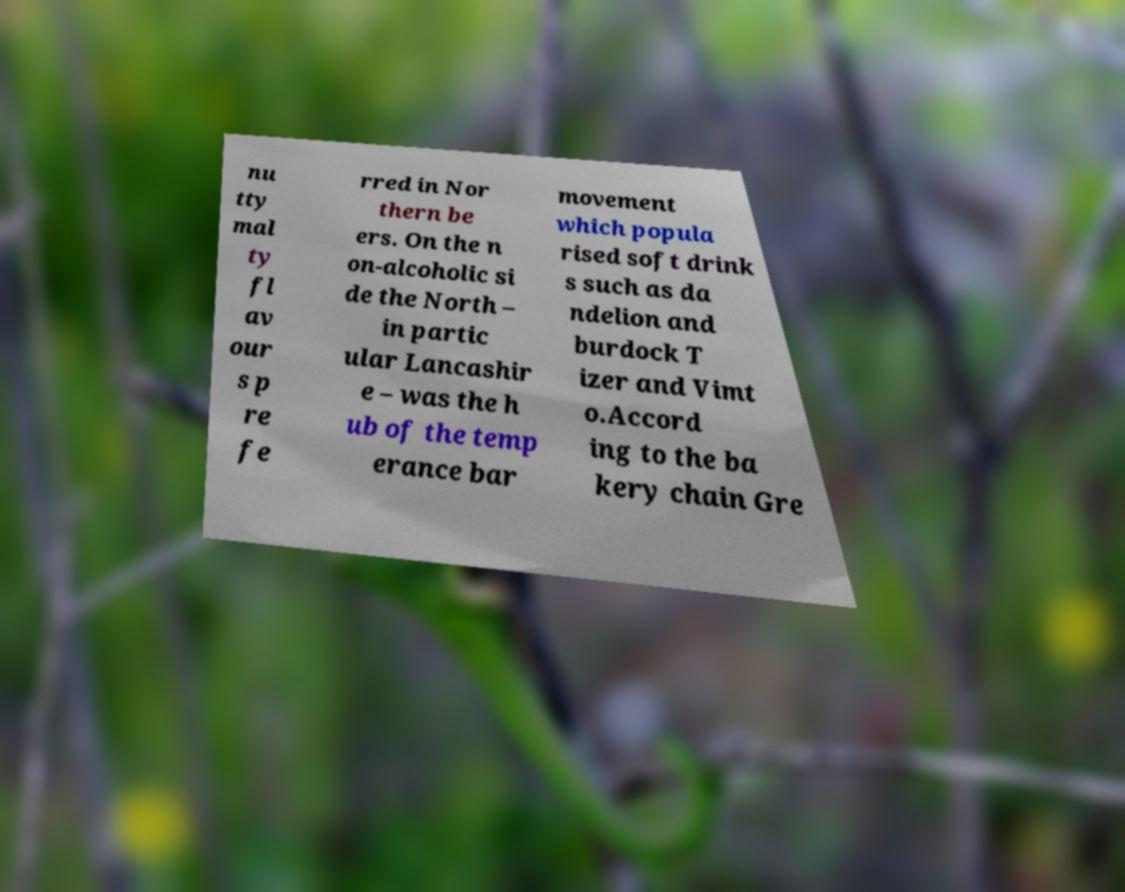Can you read and provide the text displayed in the image?This photo seems to have some interesting text. Can you extract and type it out for me? nu tty mal ty fl av our s p re fe rred in Nor thern be ers. On the n on-alcoholic si de the North – in partic ular Lancashir e – was the h ub of the temp erance bar movement which popula rised soft drink s such as da ndelion and burdock T izer and Vimt o.Accord ing to the ba kery chain Gre 